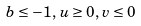Convert formula to latex. <formula><loc_0><loc_0><loc_500><loc_500>b \leq - 1 , \, u \geq 0 , \, v \leq 0</formula> 